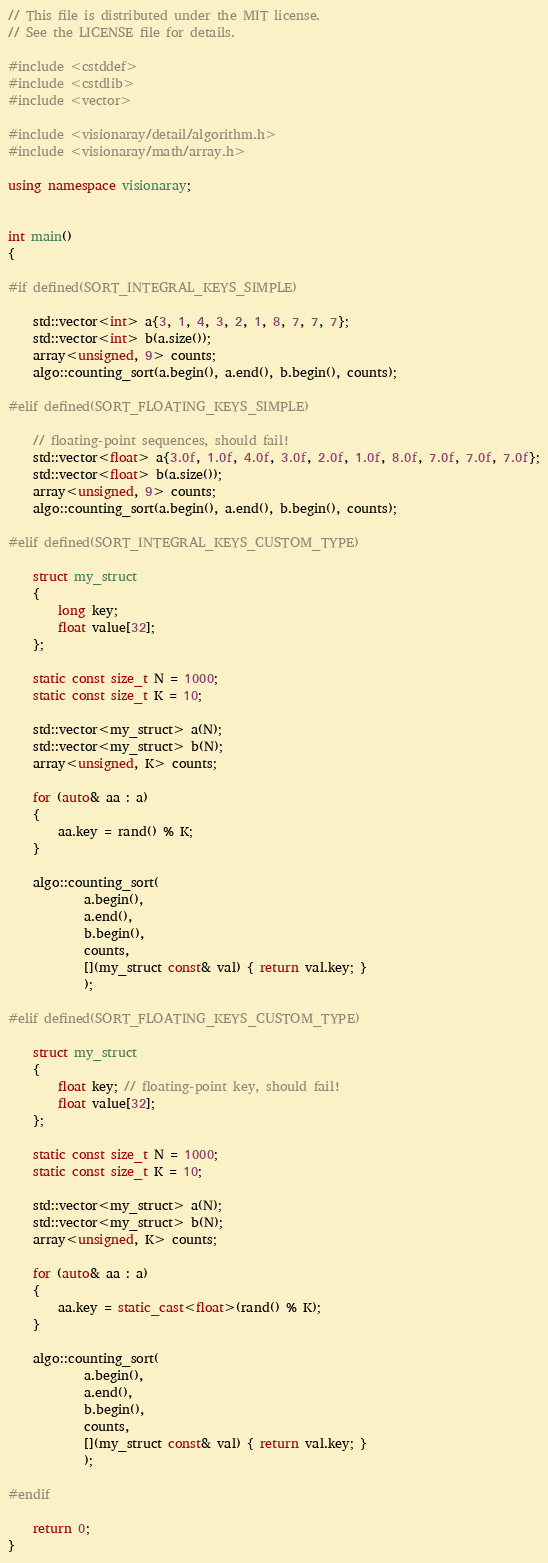Convert code to text. <code><loc_0><loc_0><loc_500><loc_500><_C++_>// This file is distributed under the MIT license.
// See the LICENSE file for details.

#include <cstddef>
#include <cstdlib>
#include <vector>

#include <visionaray/detail/algorithm.h>
#include <visionaray/math/array.h>

using namespace visionaray;


int main()
{

#if defined(SORT_INTEGRAL_KEYS_SIMPLE)

    std::vector<int> a{3, 1, 4, 3, 2, 1, 8, 7, 7, 7};
    std::vector<int> b(a.size());
    array<unsigned, 9> counts;
    algo::counting_sort(a.begin(), a.end(), b.begin(), counts);

#elif defined(SORT_FLOATING_KEYS_SIMPLE)

    // floating-point sequences, should fail!
    std::vector<float> a{3.0f, 1.0f, 4.0f, 3.0f, 2.0f, 1.0f, 8.0f, 7.0f, 7.0f, 7.0f};
    std::vector<float> b(a.size());
    array<unsigned, 9> counts;
    algo::counting_sort(a.begin(), a.end(), b.begin(), counts);

#elif defined(SORT_INTEGRAL_KEYS_CUSTOM_TYPE)

    struct my_struct
    {
        long key;
        float value[32];
    };

    static const size_t N = 1000;
    static const size_t K = 10;

    std::vector<my_struct> a(N);
    std::vector<my_struct> b(N);
    array<unsigned, K> counts;

    for (auto& aa : a)
    {
        aa.key = rand() % K;
    }

    algo::counting_sort(
            a.begin(),
            a.end(),
            b.begin(),
            counts,
            [](my_struct const& val) { return val.key; }
            );

#elif defined(SORT_FLOATING_KEYS_CUSTOM_TYPE)

    struct my_struct
    {
        float key; // floating-point key, should fail!
        float value[32];
    };

    static const size_t N = 1000;
    static const size_t K = 10;

    std::vector<my_struct> a(N);
    std::vector<my_struct> b(N);
    array<unsigned, K> counts;

    for (auto& aa : a)
    {
        aa.key = static_cast<float>(rand() % K);
    }

    algo::counting_sort(
            a.begin(),
            a.end(),
            b.begin(),
            counts,
            [](my_struct const& val) { return val.key; }
            );

#endif

    return 0;
}
</code> 